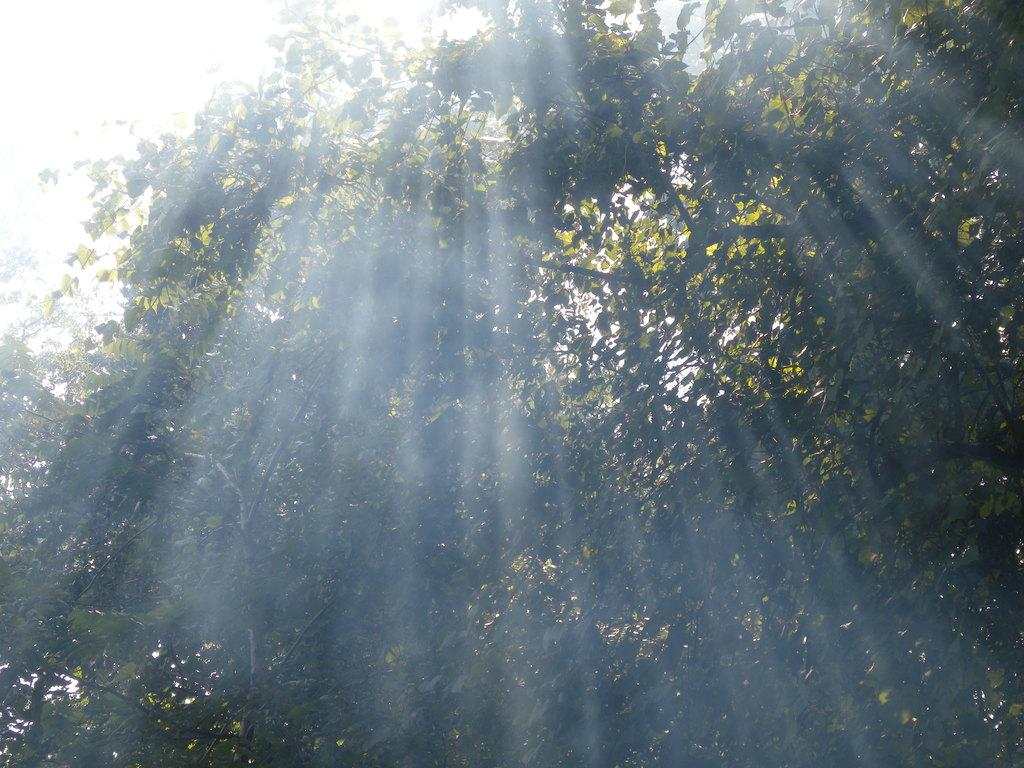What type of vegetation can be seen in the image? There are trees in the image. What color are the trees in the image? The trees are green in color. What part of the natural environment is visible in the background of the image? The sky is visible in the background of the image. What color is the sky in the image? The sky is white in color. Who is the daughter of the owner of the trees in the image? There is no information about a daughter or an owner of the trees in the image. What type of beetle can be seen crawling on the leaves of the trees in the image? There are no beetles visible on the trees in the image. 